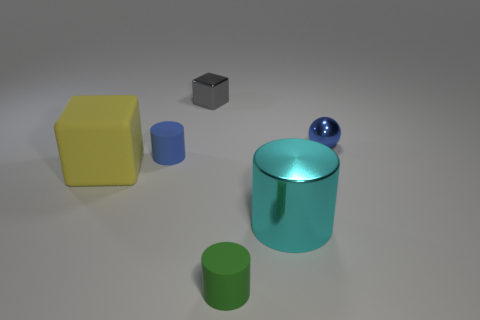There is a tiny blue object that is the same shape as the tiny green thing; what is it made of?
Ensure brevity in your answer.  Rubber. What is the color of the tiny object that is in front of the blue ball and on the left side of the small green cylinder?
Offer a very short reply. Blue. Are there any tiny blue objects right of the small metal object left of the rubber cylinder that is in front of the big cylinder?
Your answer should be compact. Yes. What number of objects are either large cyan shiny blocks or tiny objects?
Ensure brevity in your answer.  4. Is the large cyan thing made of the same material as the tiny object in front of the big yellow matte cube?
Ensure brevity in your answer.  No. Is there any other thing of the same color as the tiny shiny sphere?
Keep it short and to the point. Yes. What number of things are small objects that are behind the cyan cylinder or small rubber cylinders that are in front of the large cube?
Make the answer very short. 4. What is the shape of the metallic object that is both right of the gray cube and behind the metal cylinder?
Give a very brief answer. Sphere. What number of cylinders are behind the tiny blue object that is behind the blue matte thing?
Offer a terse response. 0. What number of things are blocks in front of the blue metallic ball or tiny purple metal spheres?
Your answer should be very brief. 1. 